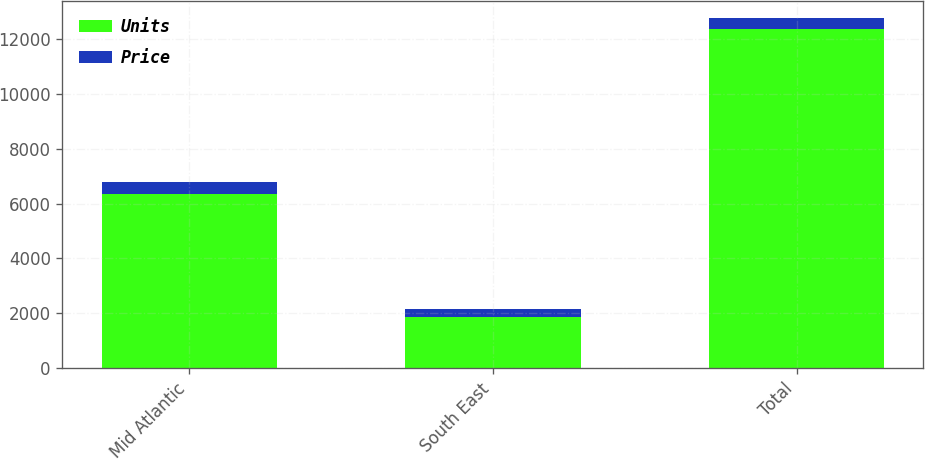Convert chart. <chart><loc_0><loc_0><loc_500><loc_500><stacked_bar_chart><ecel><fcel>Mid Atlantic<fcel>South East<fcel>Total<nl><fcel>Units<fcel>6365<fcel>1879<fcel>12389<nl><fcel>Price<fcel>431.4<fcel>278.1<fcel>373.7<nl></chart> 